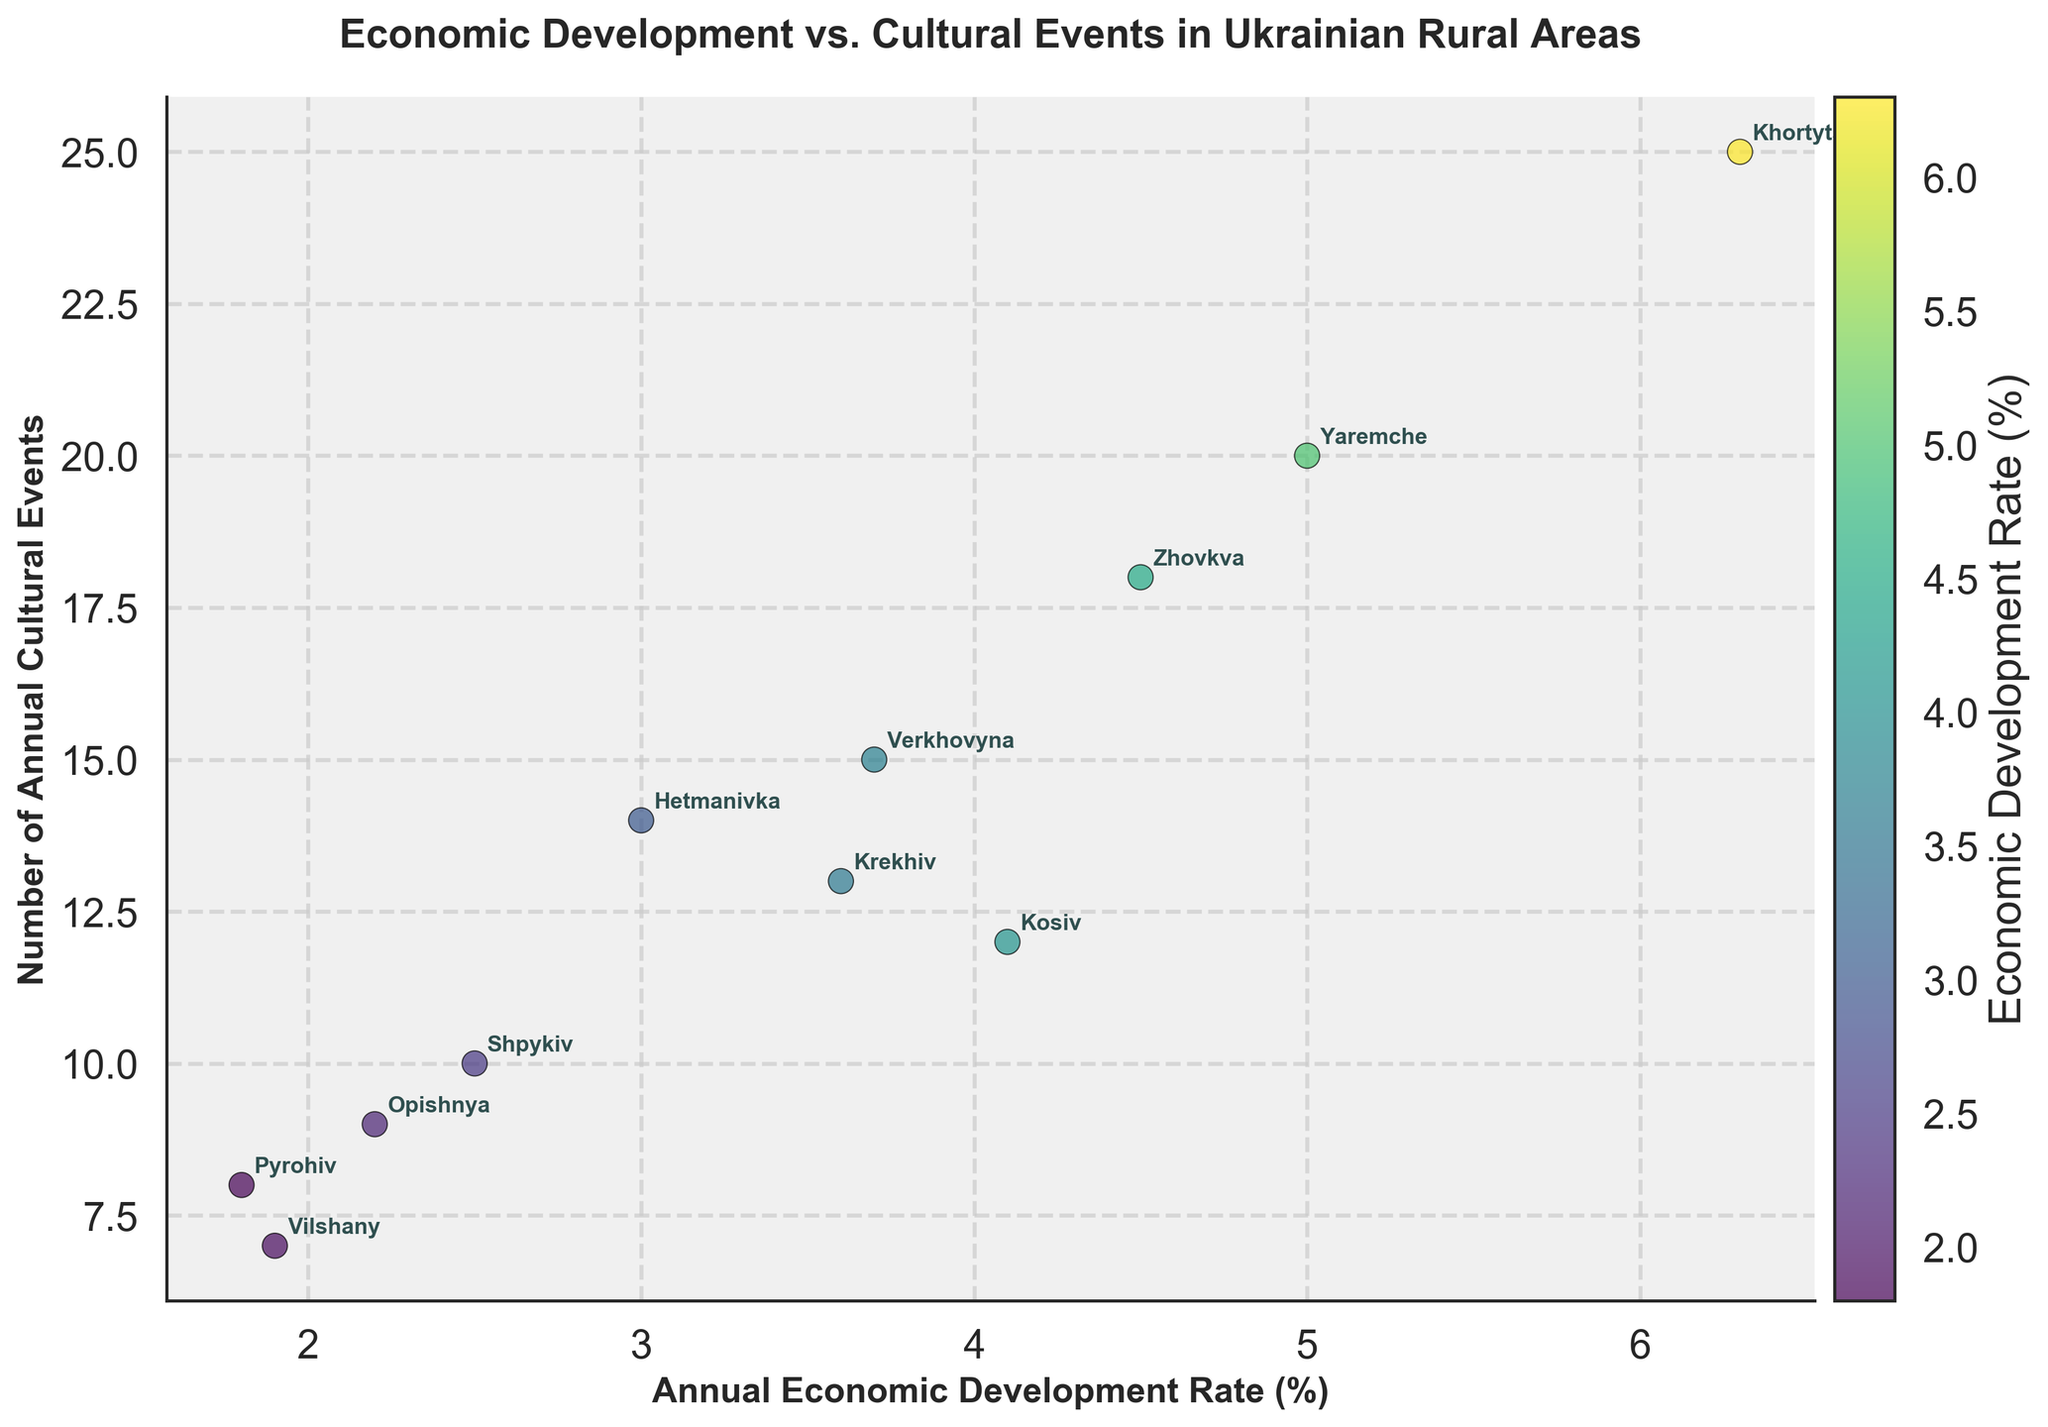What's the title of the scatter plot? The title is usually displayed at the top of the plot, prominently showing what the data represents.
Answer: Economic Development vs. Cultural Events in Ukrainian Rural Areas Which village has the highest annual economic development rate? By looking at the X-axis and finding the point farthest to the right, we determine the village name from the annotations.
Answer: Khortytsia How many cultural events does the village with a 4.5% economic development rate have? Identify the point on the X-axis at 4.5%, then read its corresponding Y-value and find the village annotation.
Answer: 18 What is the average number of annual cultural events of villages with an economic development rate greater than 4%? Identify villages with >4% development rate (Kosiv, Yaremche, Khortytsia, Zhovkva). Add their cultural events (12+20+25+18) and divide by 4.
Answer: 18.75 Which village has the lowest number of cultural events? Find the point closest to the bottom of the Y-axis, read its X-value and village annotation.
Answer: Vilshany Is there a visible correlation between the annual economic development rate and the number of annual cultural events? Observe the general trend of the scatter plot points to see if higher economic development rates align with higher numbers of events.
Answer: Yes, generally positive Which two villages have a very similar number of annual cultural events but different economic development rates? Look for villages with close Y-values but different X-values.
Answer: Shpykiv and Opishnya (both 9-10 events, different rates) What is the combined economic development rate of Shpykiv, Pyrohiv, and Vilshany? Add the development rates of these villages (2.5 + 1.8 + 1.9).
Answer: 6.2% Which village is closest to having a balanced number between annual economic development rate and cultural events? Find village where X and Y values are numerically closest.
Answer: Verkhovyna (3.7% rate, 15 events) 